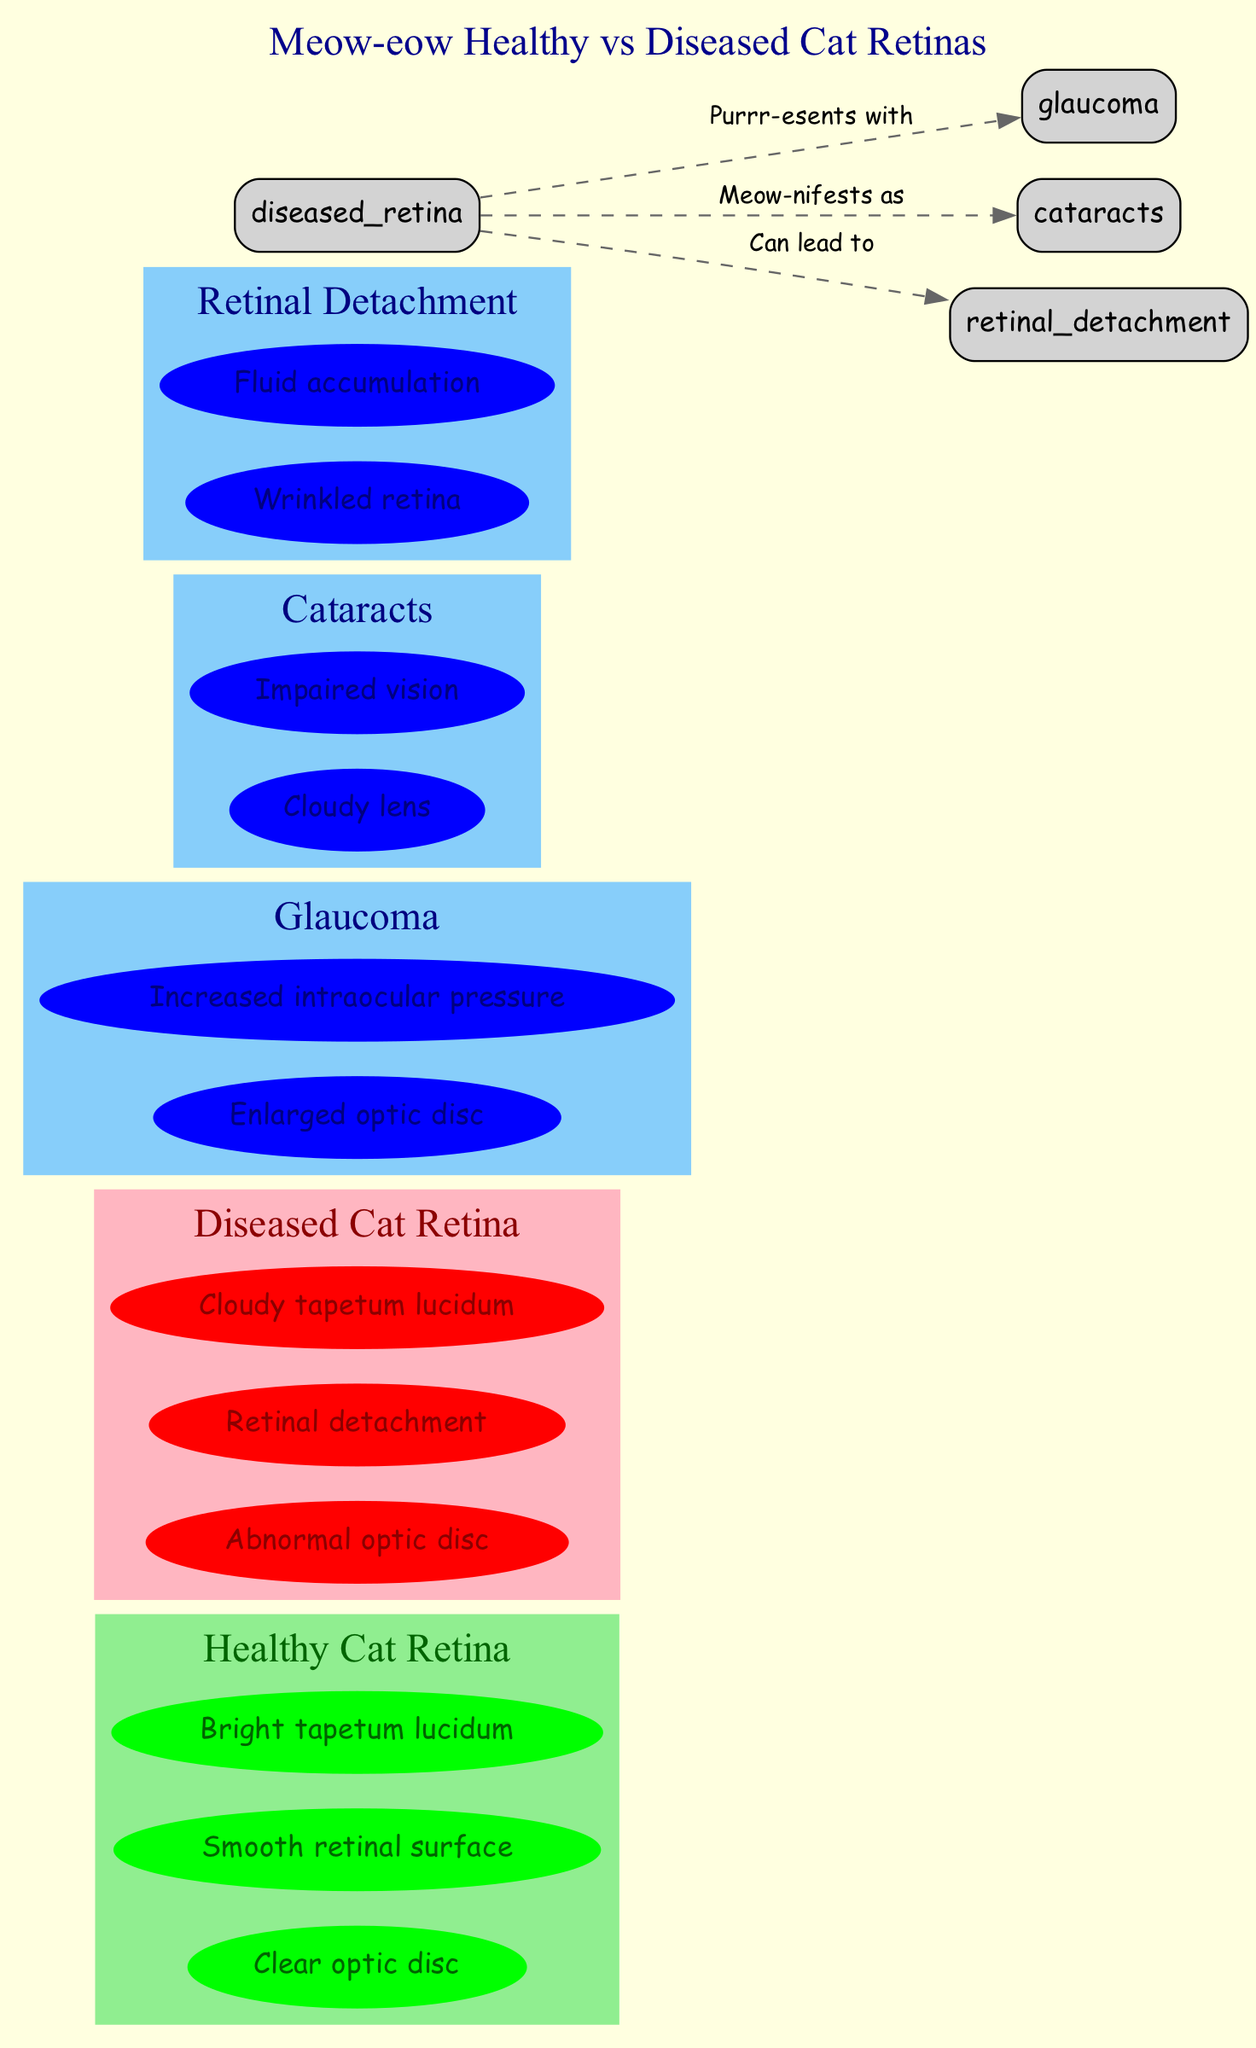What are the features of a healthy cat retina? The features of a healthy cat retina include "Clear optic disc," "Smooth retinal surface," and "Bright tapetum lucidum," which are listed under the Healthy Cat Retina node in the diagram.
Answer: Clear optic disc, Smooth retinal surface, Bright tapetum lucidum What symptoms are associated with glaucoma? The symptoms of glaucoma as shown in the diagram are "Enlarged optic disc" and "Increased intraocular pressure," which can be found under the Glaucoma node.
Answer: Enlarged optic disc, Increased intraocular pressure How many edges are in the diagram? The diagram has three edges connecting the diseased retina to the glaucoma, cataracts, and retinal detachment nodes, which can be counted at the connections between nodes.
Answer: 3 What can lead to retinal detachment? The diagram indicates that a diseased retina can lead to retinal detachment, as depicted by the edge labeled "Can lead to."
Answer: Diseased Cat Retina What are the symptoms of retinal detachment? The symptoms listed for retinal detachment are "Wrinkled retina" and "Fluid accumulation," which can be found under the Retinal Detachment node in the diagram.
Answer: Wrinkled retina, Fluid accumulation What features are displayed for the diseased cat retina? The features of a diseased cat retina, as shown in the diagram, include "Abnormal optic disc," "Retinal detachment," and "Cloudy tapetum lucidum," found under the Diseased Cat Retina node.
Answer: Abnormal optic disc, Retinal detachment, Cloudy tapetum lucidum Which condition manifests as cloudy lens? The diagram shows that cataracts, indicated by an edge labeled "Meow-nifests as," is the condition that manifests as a cloudy lens.
Answer: Cataracts What is the relationship between diseased cat retina and glaucoma? The relationship is defined as "Purrr-esents with," indicating that a diseased retina presents with symptoms of glaucoma as shown by the edge connecting these two nodes.
Answer: Purrr-esents with 